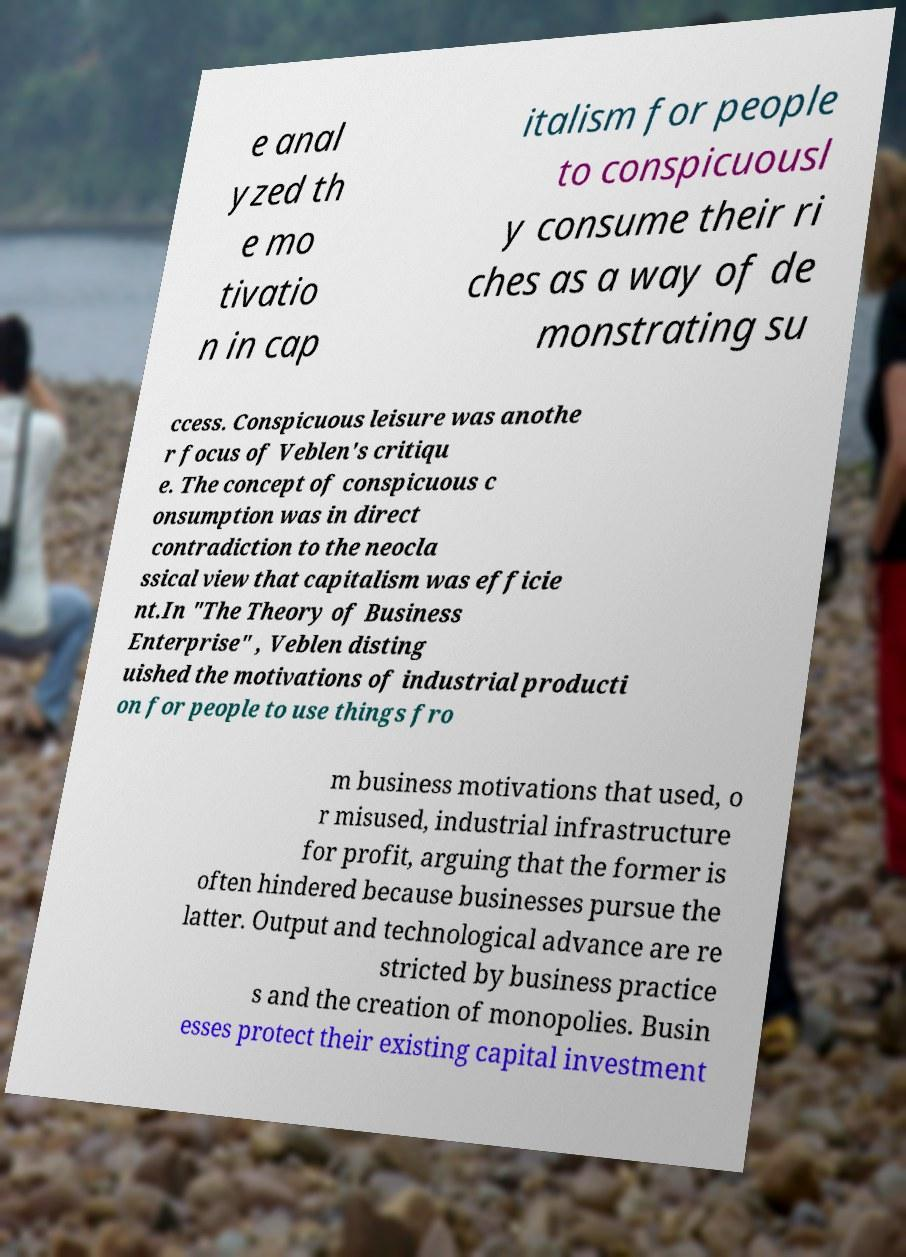There's text embedded in this image that I need extracted. Can you transcribe it verbatim? e anal yzed th e mo tivatio n in cap italism for people to conspicuousl y consume their ri ches as a way of de monstrating su ccess. Conspicuous leisure was anothe r focus of Veblen's critiqu e. The concept of conspicuous c onsumption was in direct contradiction to the neocla ssical view that capitalism was efficie nt.In "The Theory of Business Enterprise" , Veblen disting uished the motivations of industrial producti on for people to use things fro m business motivations that used, o r misused, industrial infrastructure for profit, arguing that the former is often hindered because businesses pursue the latter. Output and technological advance are re stricted by business practice s and the creation of monopolies. Busin esses protect their existing capital investment 